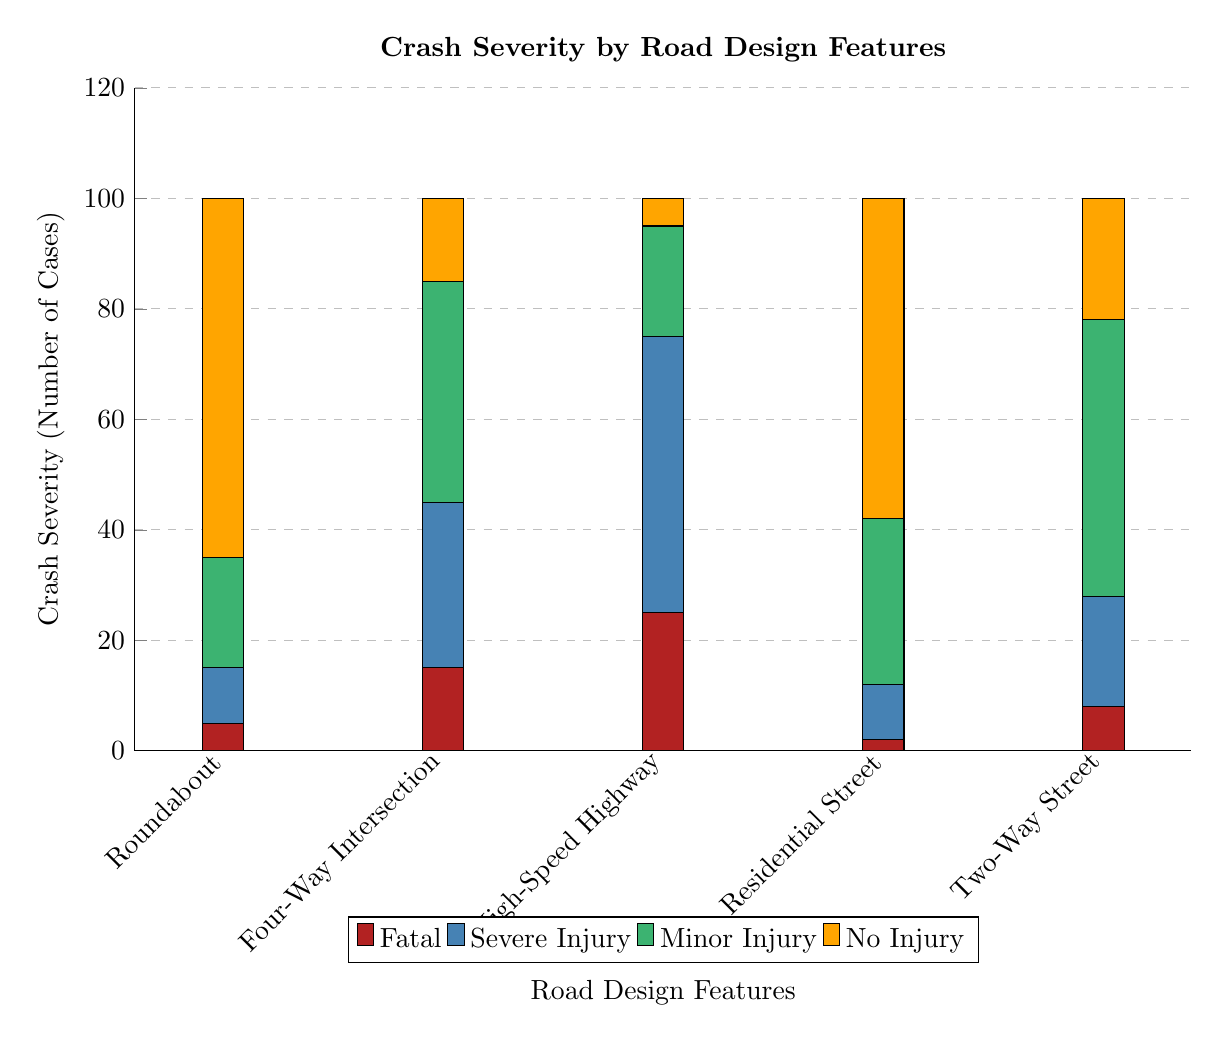What is the tallest bar in the graph? The tallest bar represents the highest number of cases of crash severity, which is associated with Roundabout and indicates the fatalities. By examining the stacked bars, the height of the Fatal category (65 cases) is the highest visible value.
Answer: 65 Which road design feature has the least number of no injury cases? To find the least number of no injury cases, look for the category labeled as "No Injury" across all road design features. The Residential Street has 58 cases, which is lower than the other features when counted.
Answer: 58 How many total severe injury cases are reported for Four-Way Intersection? To calculate the total severe injury cases for the Four-Way Intersection, we look at the specific colored bar for "Severe Injury," which shows 30 cases. This is a direct read from the diagram.
Answer: 30 Which road design feature has the most minor injury cases? The road design feature with the highest minor injury cases can be identified by examining the green section representing "Minor Injury." The Two-Way Street displays 50 cases in this category, which is the highest compared to others.
Answer: 50 What is the total number of fatal cases across all road design features? To get the total number of fatal cases, sum the values for the Fatal category from each feature: 5 (Roundabout) + 15 (Four-Way Intersection) + 25 (High-Speed Highway) + 2 (Residential Street) + 8 (Two-Way Street) = 55. This requires addition of the Fatal case values shown in the diagram.
Answer: 55 Which road design feature has the maximum number of crash severity cases? The maximum number of crash severity cases can be determined by looking at the total height of bars for each road design feature. In this scenario, the Roundabout has the highest total crash severity stacked to 100 cases. This is identified through assessing the total height.
Answer: 100 